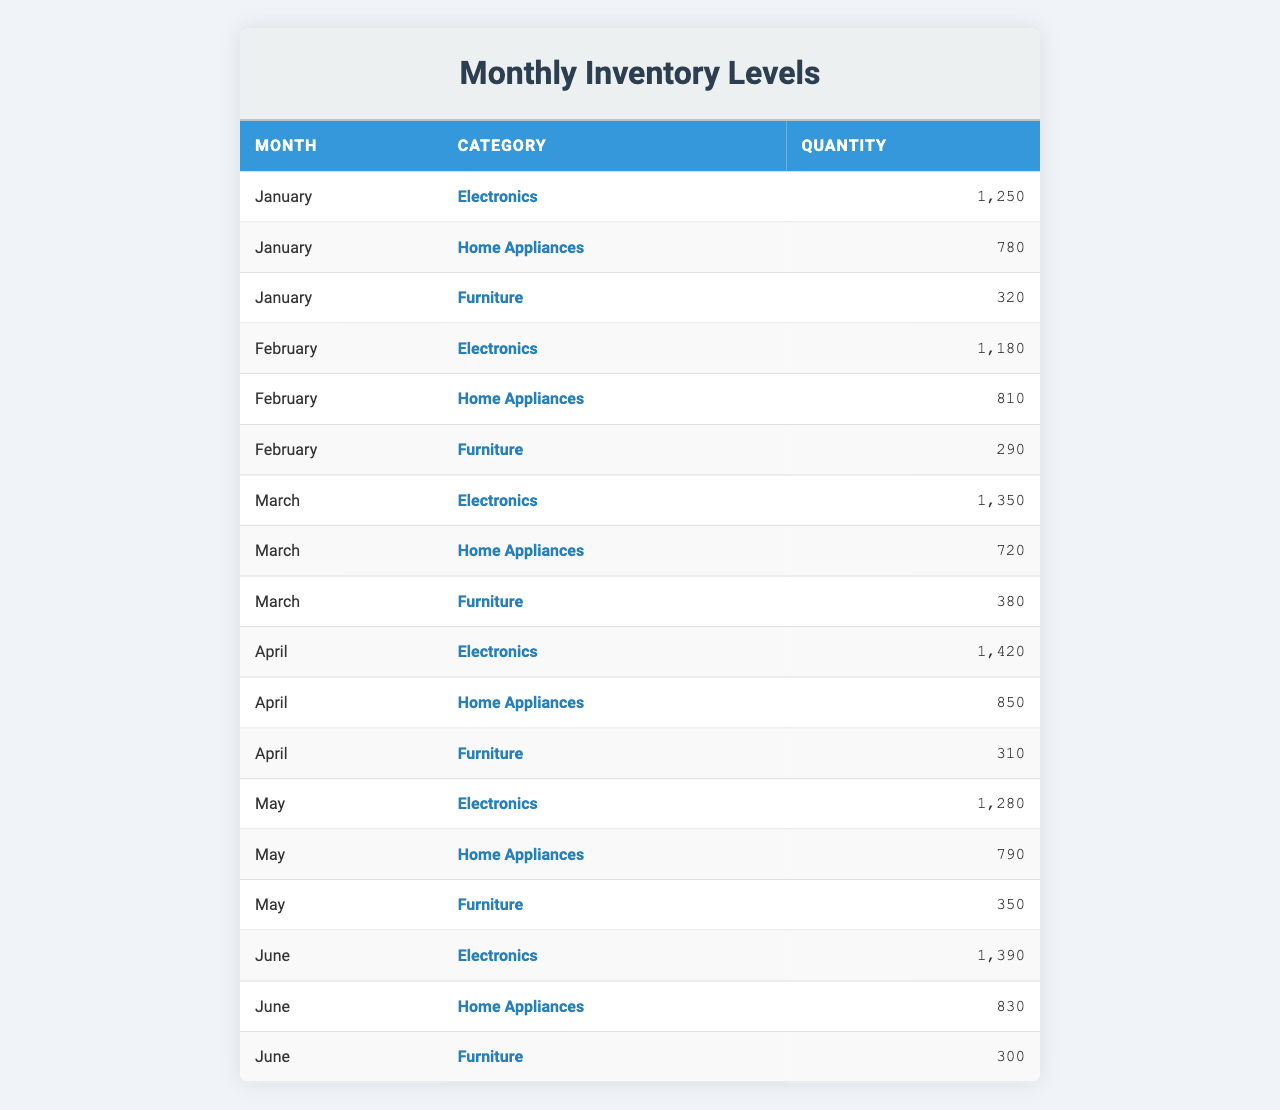What was the quantity of Electronics in January? The table shows that in January, the quantity for Electronics was specifically listed as 1250.
Answer: 1250 What is the total quantity of Home Appliances for the months of February and March? The quantities for Home Appliances in February and March are 810 and 720, respectively. Summing these values gives 810 + 720 = 1530.
Answer: 1530 Did the quantity of Furniture increase or decrease from January to April? In January, the quantity of Furniture was 320, and in April, it was 310. Since 310 is less than 320, it indicates a decrease.
Answer: Decrease What was the average quantity of Electronics across all months listed? The monthly quantities for Electronics are 1250, 1180, 1350, 1420, 1280, and 1390. Adding these values gives 1250 + 1180 + 1350 + 1420 + 1280 + 1390 = 7,870. There are 6 months, so dividing gives 7870 / 6 = 1311.67.
Answer: 1311.67 Which month had the highest quantity of Furniture? Reviewing the monthly values for Furniture reveals that in March, the quantity was the highest at 380, compared to January (320), February (290), April (310), and June (300).
Answer: March What is the difference in quantity between Electronics and Home Appliances in May? In May, the quantity of Electronics was 1280 and Home Appliances was 790. The difference is calculated by subtracting the latter from the former: 1280 - 790 = 490.
Answer: 490 Is the total quantity of Home Appliances greater than 4000 for the first six months? The quantities for Home Appliances over the first six months are 780 (January) + 810 (February) + 720 (March) + 850 (April) + 790 (May) + 830 (June). Summing these yields 780 + 810 + 720 + 850 + 790 + 830 = 3980, which is less than 4000.
Answer: No Which category had the lowest quantity in February? In February, the quantities were 1180 for Electronics, 810 for Home Appliances, and 290 for Furniture. The lowest of these is 290 for Furniture.
Answer: Furniture What was the total quantity of all categories in June? For June, the quantities were: 1390 (Electronics), 830 (Home Appliances), and 300 (Furniture). Summing these yields 1390 + 830 + 300 = 2520.
Answer: 2520 Can you identify a month where the quantity of Home Appliances was lower than that of Furniture? In March, the quantity of Home Appliances was 720 while Furniture had 380, making Home Appliances greater than Furniture for that month. However, no month has Home Appliances lower than Furniture since in every month both categories are either equal or Home Appliances are higher.
Answer: No 